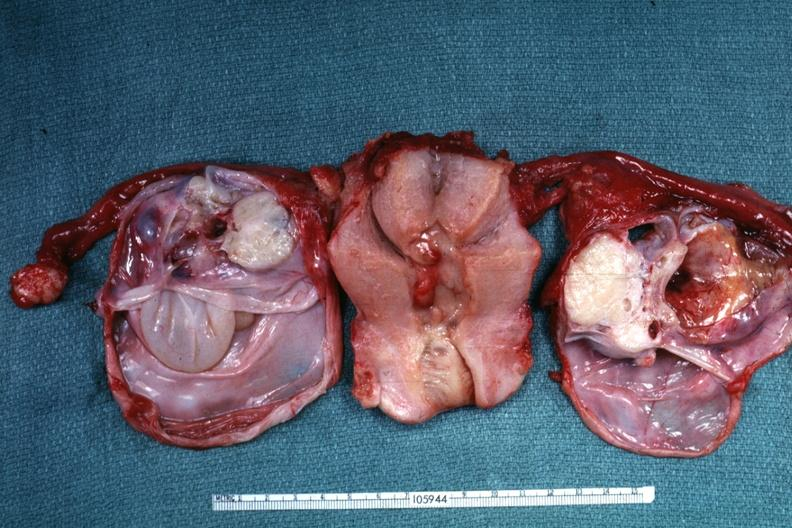what have ovaries been cut of tumor masses?
Answer the question using a single word or phrase. Been to show multiloculated nature 